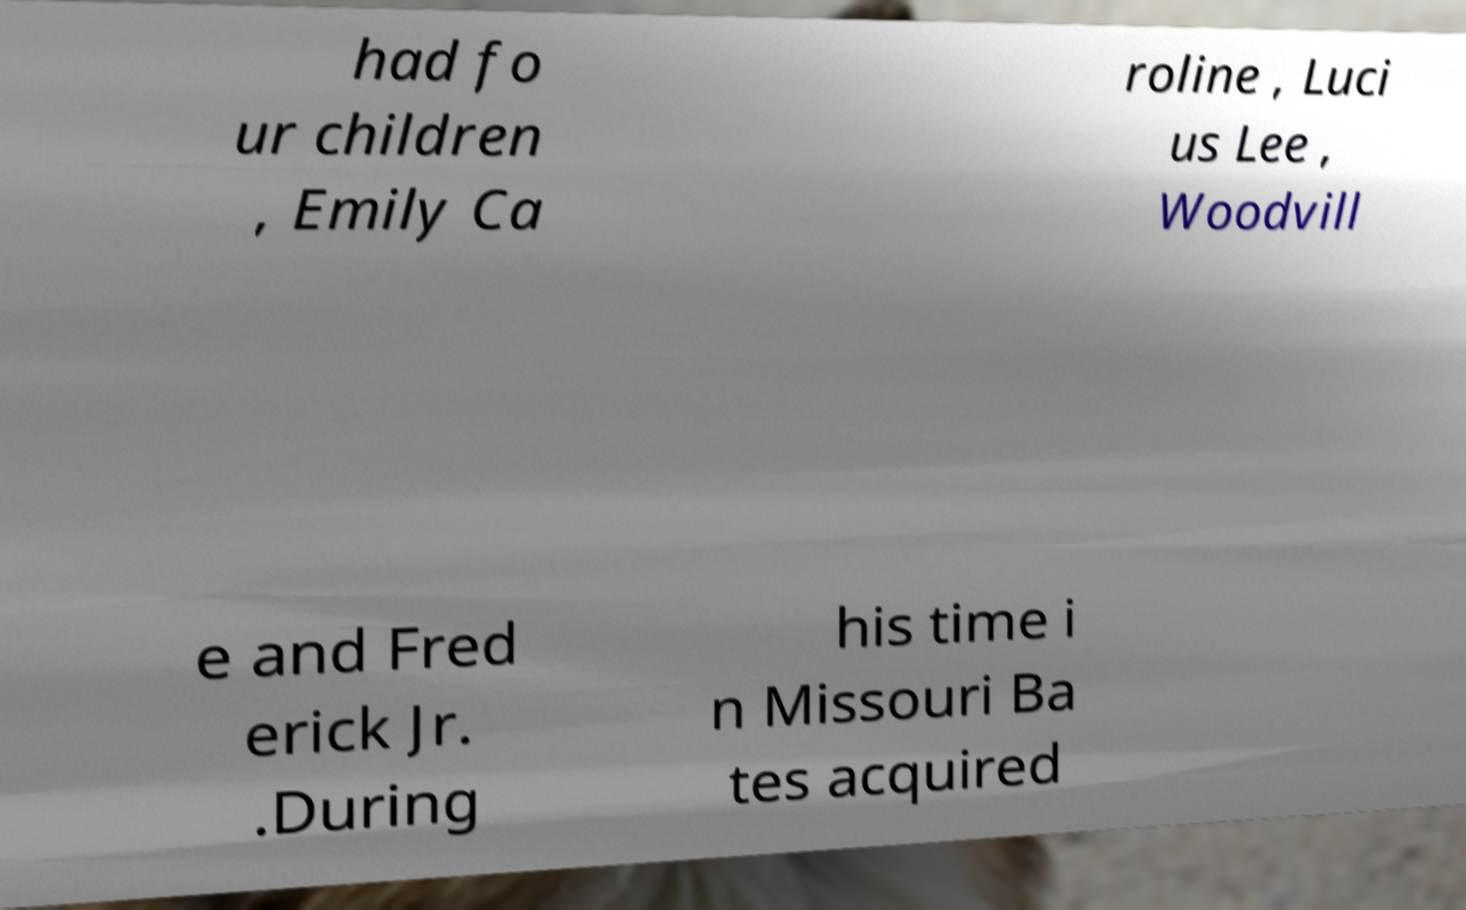Can you read and provide the text displayed in the image?This photo seems to have some interesting text. Can you extract and type it out for me? had fo ur children , Emily Ca roline , Luci us Lee , Woodvill e and Fred erick Jr. .During his time i n Missouri Ba tes acquired 